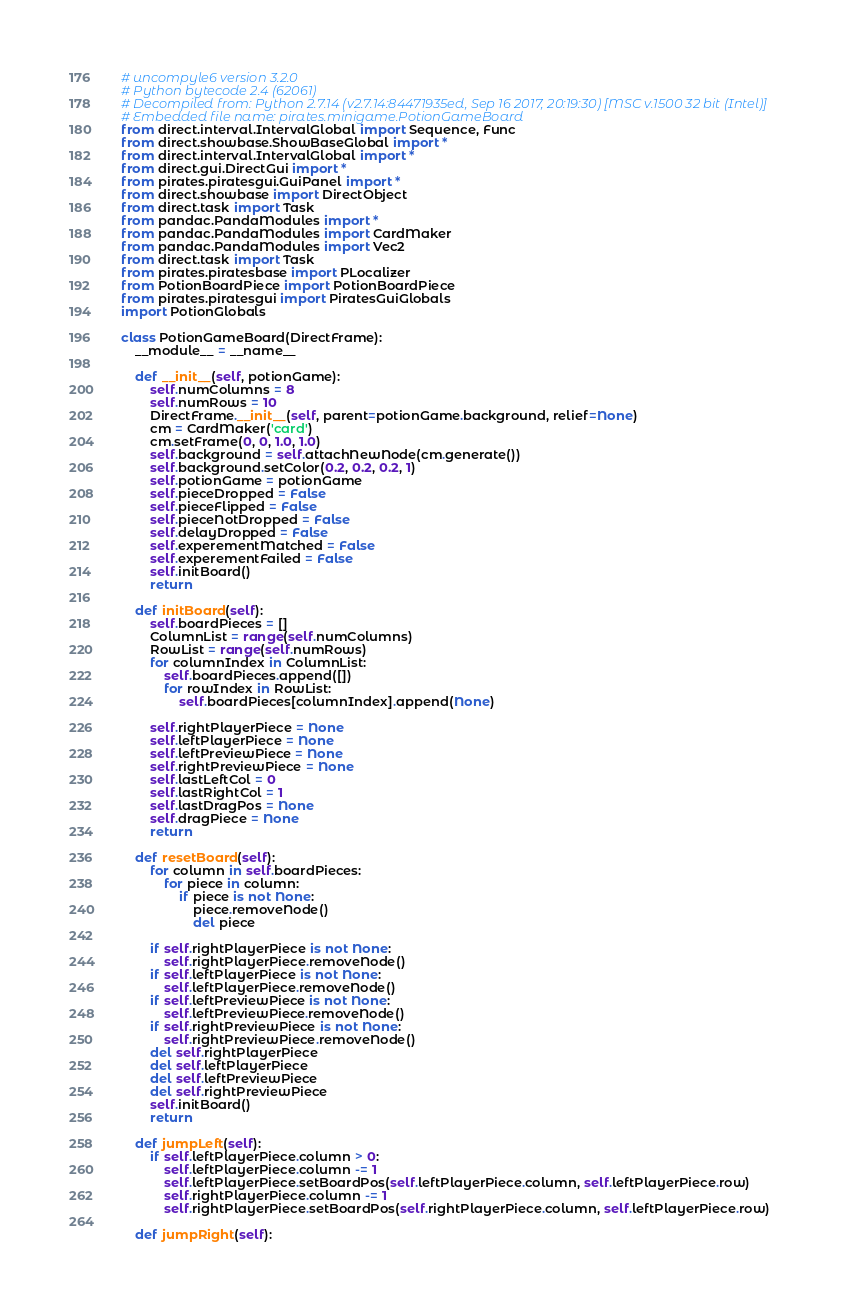Convert code to text. <code><loc_0><loc_0><loc_500><loc_500><_Python_># uncompyle6 version 3.2.0
# Python bytecode 2.4 (62061)
# Decompiled from: Python 2.7.14 (v2.7.14:84471935ed, Sep 16 2017, 20:19:30) [MSC v.1500 32 bit (Intel)]
# Embedded file name: pirates.minigame.PotionGameBoard
from direct.interval.IntervalGlobal import Sequence, Func
from direct.showbase.ShowBaseGlobal import *
from direct.interval.IntervalGlobal import *
from direct.gui.DirectGui import *
from pirates.piratesgui.GuiPanel import *
from direct.showbase import DirectObject
from direct.task import Task
from pandac.PandaModules import *
from pandac.PandaModules import CardMaker
from pandac.PandaModules import Vec2
from direct.task import Task
from pirates.piratesbase import PLocalizer
from PotionBoardPiece import PotionBoardPiece
from pirates.piratesgui import PiratesGuiGlobals
import PotionGlobals

class PotionGameBoard(DirectFrame):
    __module__ = __name__

    def __init__(self, potionGame):
        self.numColumns = 8
        self.numRows = 10
        DirectFrame.__init__(self, parent=potionGame.background, relief=None)
        cm = CardMaker('card')
        cm.setFrame(0, 0, 1.0, 1.0)
        self.background = self.attachNewNode(cm.generate())
        self.background.setColor(0.2, 0.2, 0.2, 1)
        self.potionGame = potionGame
        self.pieceDropped = False
        self.pieceFlipped = False
        self.pieceNotDropped = False
        self.delayDropped = False
        self.experementMatched = False
        self.experementFailed = False
        self.initBoard()
        return

    def initBoard(self):
        self.boardPieces = []
        ColumnList = range(self.numColumns)
        RowList = range(self.numRows)
        for columnIndex in ColumnList:
            self.boardPieces.append([])
            for rowIndex in RowList:
                self.boardPieces[columnIndex].append(None)

        self.rightPlayerPiece = None
        self.leftPlayerPiece = None
        self.leftPreviewPiece = None
        self.rightPreviewPiece = None
        self.lastLeftCol = 0
        self.lastRightCol = 1
        self.lastDragPos = None
        self.dragPiece = None
        return

    def resetBoard(self):
        for column in self.boardPieces:
            for piece in column:
                if piece is not None:
                    piece.removeNode()
                    del piece

        if self.rightPlayerPiece is not None:
            self.rightPlayerPiece.removeNode()
        if self.leftPlayerPiece is not None:
            self.leftPlayerPiece.removeNode()
        if self.leftPreviewPiece is not None:
            self.leftPreviewPiece.removeNode()
        if self.rightPreviewPiece is not None:
            self.rightPreviewPiece.removeNode()
        del self.rightPlayerPiece
        del self.leftPlayerPiece
        del self.leftPreviewPiece
        del self.rightPreviewPiece
        self.initBoard()
        return

    def jumpLeft(self):
        if self.leftPlayerPiece.column > 0:
            self.leftPlayerPiece.column -= 1
            self.leftPlayerPiece.setBoardPos(self.leftPlayerPiece.column, self.leftPlayerPiece.row)
            self.rightPlayerPiece.column -= 1
            self.rightPlayerPiece.setBoardPos(self.rightPlayerPiece.column, self.leftPlayerPiece.row)

    def jumpRight(self):</code> 